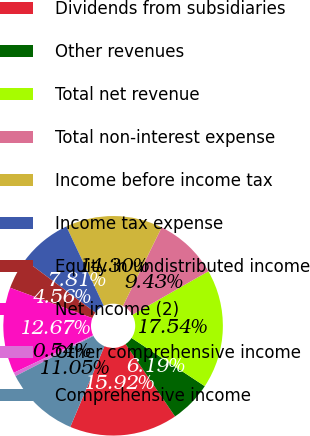<chart> <loc_0><loc_0><loc_500><loc_500><pie_chart><fcel>Dividends from subsidiaries<fcel>Other revenues<fcel>Total net revenue<fcel>Total non-interest expense<fcel>Income before income tax<fcel>Income tax expense<fcel>Equity in undistributed income<fcel>Net income (2)<fcel>Other comprehensive income<fcel>Comprehensive income<nl><fcel>15.92%<fcel>6.19%<fcel>17.54%<fcel>9.43%<fcel>14.3%<fcel>7.81%<fcel>4.56%<fcel>12.67%<fcel>0.54%<fcel>11.05%<nl></chart> 